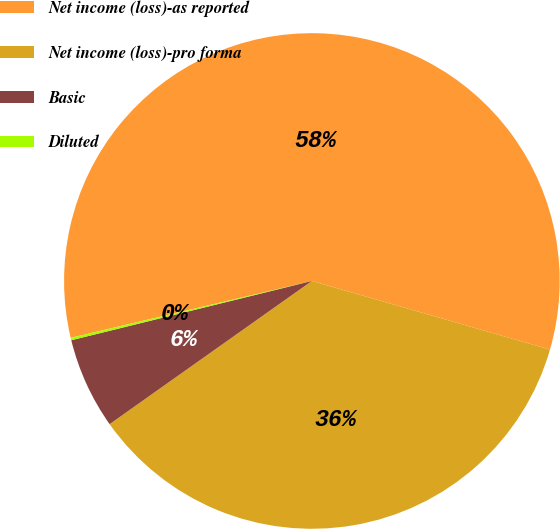Convert chart to OTSL. <chart><loc_0><loc_0><loc_500><loc_500><pie_chart><fcel>Net income (loss)-as reported<fcel>Net income (loss)-pro forma<fcel>Basic<fcel>Diluted<nl><fcel>58.15%<fcel>35.73%<fcel>5.96%<fcel>0.16%<nl></chart> 